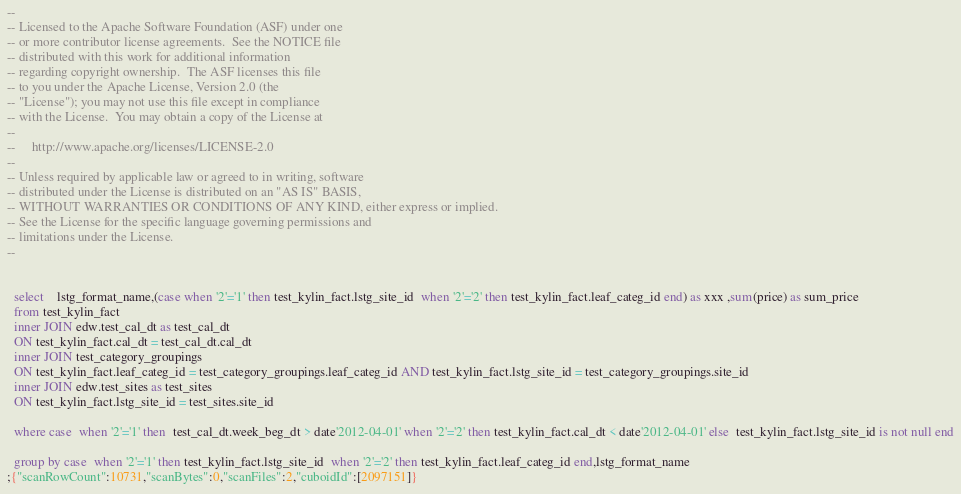Convert code to text. <code><loc_0><loc_0><loc_500><loc_500><_SQL_>--
-- Licensed to the Apache Software Foundation (ASF) under one
-- or more contributor license agreements.  See the NOTICE file
-- distributed with this work for additional information
-- regarding copyright ownership.  The ASF licenses this file
-- to you under the Apache License, Version 2.0 (the
-- "License"); you may not use this file except in compliance
-- with the License.  You may obtain a copy of the License at
--
--     http://www.apache.org/licenses/LICENSE-2.0
--
-- Unless required by applicable law or agreed to in writing, software
-- distributed under the License is distributed on an "AS IS" BASIS,
-- WITHOUT WARRANTIES OR CONDITIONS OF ANY KIND, either express or implied.
-- See the License for the specific language governing permissions and
-- limitations under the License.
--


  select    lstg_format_name,(case when '2'='1' then test_kylin_fact.lstg_site_id  when '2'='2' then test_kylin_fact.leaf_categ_id end) as xxx ,sum(price) as sum_price
  from test_kylin_fact
  inner JOIN edw.test_cal_dt as test_cal_dt
  ON test_kylin_fact.cal_dt = test_cal_dt.cal_dt
  inner JOIN test_category_groupings
  ON test_kylin_fact.leaf_categ_id = test_category_groupings.leaf_categ_id AND test_kylin_fact.lstg_site_id = test_category_groupings.site_id
  inner JOIN edw.test_sites as test_sites
  ON test_kylin_fact.lstg_site_id = test_sites.site_id

  where case  when '2'='1' then  test_cal_dt.week_beg_dt > date'2012-04-01' when '2'='2' then test_kylin_fact.cal_dt < date'2012-04-01' else  test_kylin_fact.lstg_site_id is not null end

  group by case  when '2'='1' then test_kylin_fact.lstg_site_id  when '2'='2' then test_kylin_fact.leaf_categ_id end,lstg_format_name
;{"scanRowCount":10731,"scanBytes":0,"scanFiles":2,"cuboidId":[2097151]}</code> 